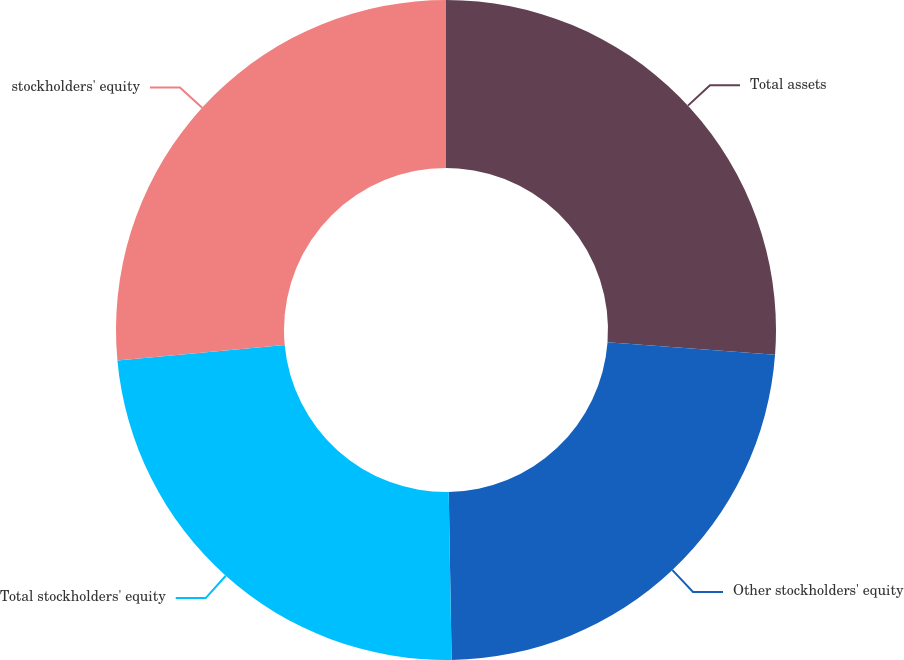<chart> <loc_0><loc_0><loc_500><loc_500><pie_chart><fcel>Total assets<fcel>Other stockholders' equity<fcel>Total stockholders' equity<fcel>stockholders' equity<nl><fcel>26.2%<fcel>23.53%<fcel>23.8%<fcel>26.47%<nl></chart> 